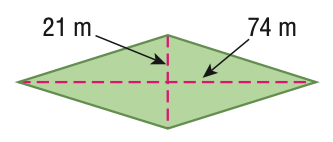Question: Find the area of the figure. Round to the nearest tenth if necessary.
Choices:
A. 190
B. 1554
C. 3108
D. 6216
Answer with the letter. Answer: C 